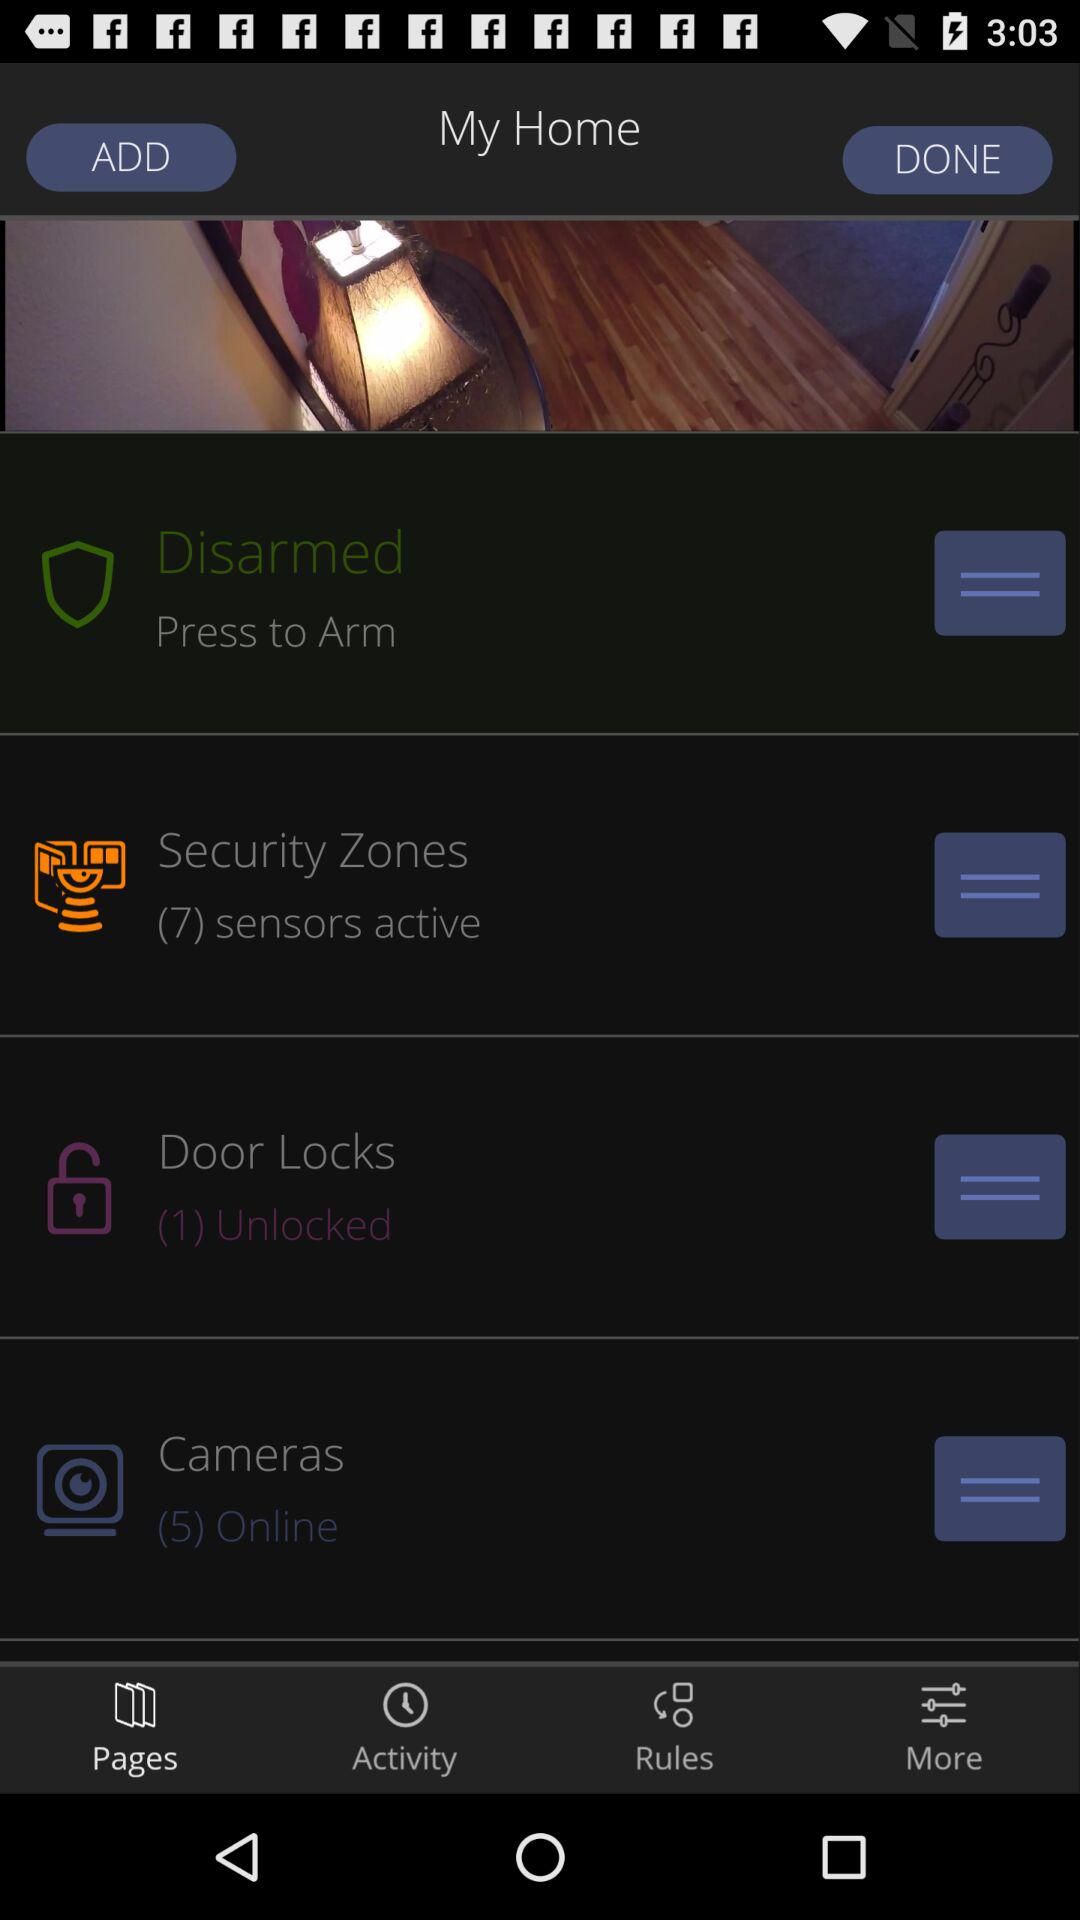How many cameras are online? There are 5 cameras that are online. 